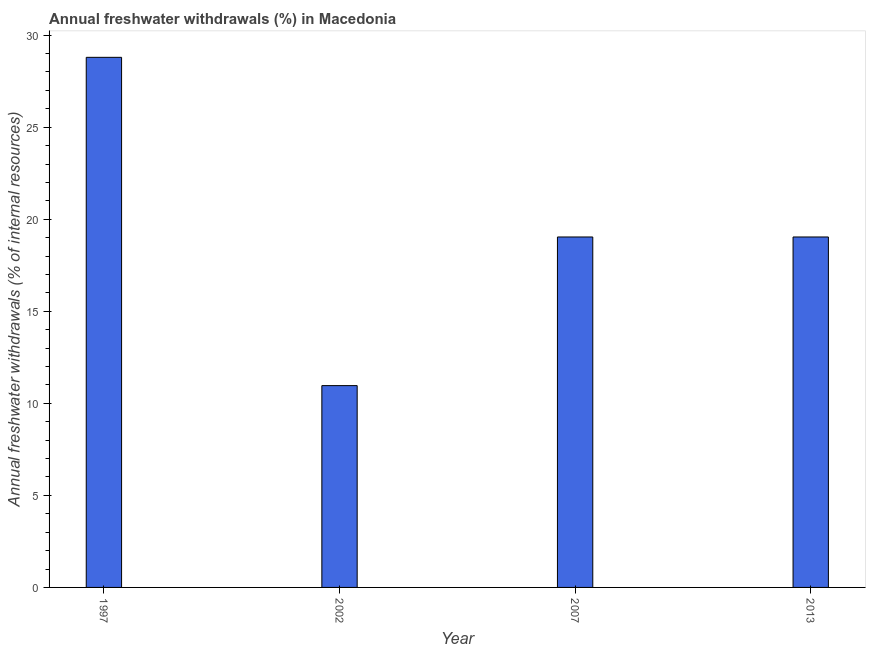Does the graph contain grids?
Make the answer very short. No. What is the title of the graph?
Give a very brief answer. Annual freshwater withdrawals (%) in Macedonia. What is the label or title of the Y-axis?
Give a very brief answer. Annual freshwater withdrawals (% of internal resources). What is the annual freshwater withdrawals in 1997?
Offer a terse response. 28.8. Across all years, what is the maximum annual freshwater withdrawals?
Give a very brief answer. 28.8. Across all years, what is the minimum annual freshwater withdrawals?
Give a very brief answer. 10.96. In which year was the annual freshwater withdrawals maximum?
Keep it short and to the point. 1997. In which year was the annual freshwater withdrawals minimum?
Keep it short and to the point. 2002. What is the sum of the annual freshwater withdrawals?
Make the answer very short. 77.83. What is the difference between the annual freshwater withdrawals in 2002 and 2007?
Provide a succinct answer. -8.07. What is the average annual freshwater withdrawals per year?
Provide a short and direct response. 19.46. What is the median annual freshwater withdrawals?
Provide a short and direct response. 19.04. Do a majority of the years between 2002 and 1997 (inclusive) have annual freshwater withdrawals greater than 26 %?
Make the answer very short. No. What is the ratio of the annual freshwater withdrawals in 1997 to that in 2002?
Offer a terse response. 2.63. Is the annual freshwater withdrawals in 1997 less than that in 2007?
Offer a very short reply. No. Is the difference between the annual freshwater withdrawals in 2007 and 2013 greater than the difference between any two years?
Offer a very short reply. No. What is the difference between the highest and the second highest annual freshwater withdrawals?
Ensure brevity in your answer.  9.76. Is the sum of the annual freshwater withdrawals in 2002 and 2007 greater than the maximum annual freshwater withdrawals across all years?
Your response must be concise. Yes. What is the difference between the highest and the lowest annual freshwater withdrawals?
Offer a terse response. 17.83. How many bars are there?
Make the answer very short. 4. How many years are there in the graph?
Provide a succinct answer. 4. Are the values on the major ticks of Y-axis written in scientific E-notation?
Keep it short and to the point. No. What is the Annual freshwater withdrawals (% of internal resources) in 1997?
Give a very brief answer. 28.8. What is the Annual freshwater withdrawals (% of internal resources) in 2002?
Provide a short and direct response. 10.96. What is the Annual freshwater withdrawals (% of internal resources) of 2007?
Ensure brevity in your answer.  19.04. What is the Annual freshwater withdrawals (% of internal resources) of 2013?
Make the answer very short. 19.04. What is the difference between the Annual freshwater withdrawals (% of internal resources) in 1997 and 2002?
Your response must be concise. 17.83. What is the difference between the Annual freshwater withdrawals (% of internal resources) in 1997 and 2007?
Make the answer very short. 9.76. What is the difference between the Annual freshwater withdrawals (% of internal resources) in 1997 and 2013?
Your answer should be very brief. 9.76. What is the difference between the Annual freshwater withdrawals (% of internal resources) in 2002 and 2007?
Your response must be concise. -8.07. What is the difference between the Annual freshwater withdrawals (% of internal resources) in 2002 and 2013?
Your response must be concise. -8.07. What is the ratio of the Annual freshwater withdrawals (% of internal resources) in 1997 to that in 2002?
Keep it short and to the point. 2.63. What is the ratio of the Annual freshwater withdrawals (% of internal resources) in 1997 to that in 2007?
Your answer should be very brief. 1.51. What is the ratio of the Annual freshwater withdrawals (% of internal resources) in 1997 to that in 2013?
Make the answer very short. 1.51. What is the ratio of the Annual freshwater withdrawals (% of internal resources) in 2002 to that in 2007?
Keep it short and to the point. 0.58. What is the ratio of the Annual freshwater withdrawals (% of internal resources) in 2002 to that in 2013?
Provide a short and direct response. 0.58. What is the ratio of the Annual freshwater withdrawals (% of internal resources) in 2007 to that in 2013?
Keep it short and to the point. 1. 